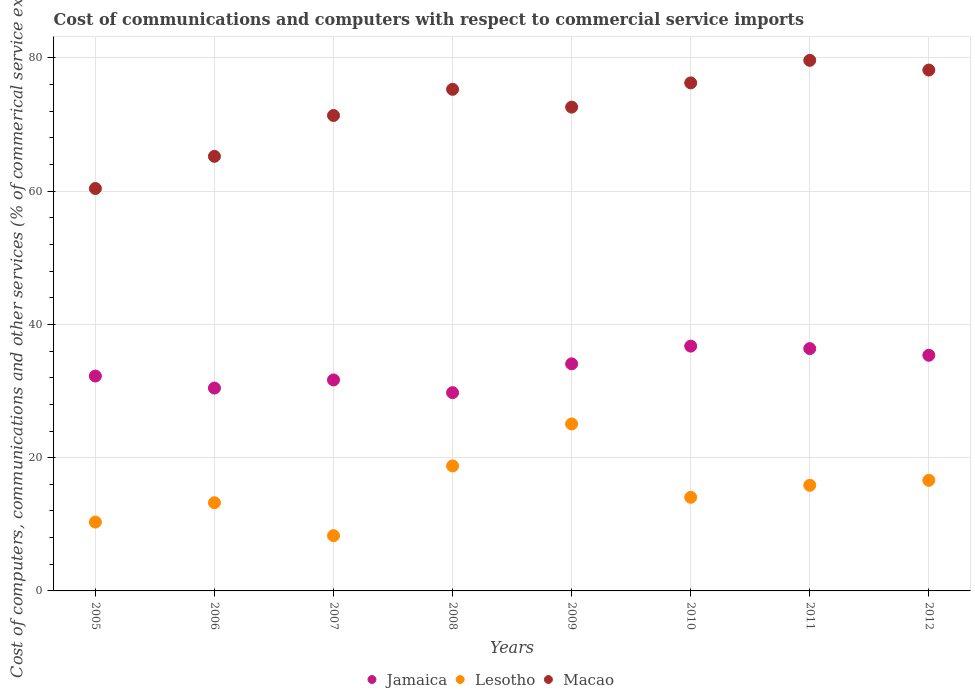Is the number of dotlines equal to the number of legend labels?
Your answer should be very brief. Yes. What is the cost of communications and computers in Lesotho in 2009?
Give a very brief answer. 25.06. Across all years, what is the maximum cost of communications and computers in Jamaica?
Offer a terse response. 36.75. Across all years, what is the minimum cost of communications and computers in Lesotho?
Give a very brief answer. 8.29. In which year was the cost of communications and computers in Macao minimum?
Offer a very short reply. 2005. What is the total cost of communications and computers in Lesotho in the graph?
Make the answer very short. 122.21. What is the difference between the cost of communications and computers in Jamaica in 2006 and that in 2012?
Offer a very short reply. -4.92. What is the difference between the cost of communications and computers in Jamaica in 2005 and the cost of communications and computers in Macao in 2007?
Your response must be concise. -39.11. What is the average cost of communications and computers in Macao per year?
Provide a succinct answer. 72.38. In the year 2007, what is the difference between the cost of communications and computers in Macao and cost of communications and computers in Jamaica?
Make the answer very short. 39.7. What is the ratio of the cost of communications and computers in Macao in 2006 to that in 2008?
Offer a very short reply. 0.87. Is the cost of communications and computers in Lesotho in 2006 less than that in 2010?
Offer a terse response. Yes. What is the difference between the highest and the second highest cost of communications and computers in Macao?
Your answer should be very brief. 1.46. What is the difference between the highest and the lowest cost of communications and computers in Jamaica?
Your response must be concise. 6.99. In how many years, is the cost of communications and computers in Macao greater than the average cost of communications and computers in Macao taken over all years?
Make the answer very short. 5. Is the sum of the cost of communications and computers in Jamaica in 2009 and 2012 greater than the maximum cost of communications and computers in Lesotho across all years?
Your response must be concise. Yes. Does the cost of communications and computers in Jamaica monotonically increase over the years?
Keep it short and to the point. No. Is the cost of communications and computers in Jamaica strictly less than the cost of communications and computers in Lesotho over the years?
Keep it short and to the point. No. How many years are there in the graph?
Keep it short and to the point. 8. What is the difference between two consecutive major ticks on the Y-axis?
Provide a succinct answer. 20. Does the graph contain grids?
Your answer should be very brief. Yes. How are the legend labels stacked?
Your response must be concise. Horizontal. What is the title of the graph?
Make the answer very short. Cost of communications and computers with respect to commercial service imports. Does "Tanzania" appear as one of the legend labels in the graph?
Provide a succinct answer. No. What is the label or title of the Y-axis?
Make the answer very short. Cost of computers, communications and other services (% of commerical service exports). What is the Cost of computers, communications and other services (% of commerical service exports) in Jamaica in 2005?
Keep it short and to the point. 32.25. What is the Cost of computers, communications and other services (% of commerical service exports) of Lesotho in 2005?
Give a very brief answer. 10.33. What is the Cost of computers, communications and other services (% of commerical service exports) of Macao in 2005?
Provide a short and direct response. 60.41. What is the Cost of computers, communications and other services (% of commerical service exports) of Jamaica in 2006?
Keep it short and to the point. 30.45. What is the Cost of computers, communications and other services (% of commerical service exports) of Lesotho in 2006?
Provide a succinct answer. 13.24. What is the Cost of computers, communications and other services (% of commerical service exports) in Macao in 2006?
Your response must be concise. 65.24. What is the Cost of computers, communications and other services (% of commerical service exports) of Jamaica in 2007?
Make the answer very short. 31.67. What is the Cost of computers, communications and other services (% of commerical service exports) in Lesotho in 2007?
Your answer should be compact. 8.29. What is the Cost of computers, communications and other services (% of commerical service exports) of Macao in 2007?
Your answer should be compact. 71.37. What is the Cost of computers, communications and other services (% of commerical service exports) in Jamaica in 2008?
Your answer should be very brief. 29.76. What is the Cost of computers, communications and other services (% of commerical service exports) in Lesotho in 2008?
Provide a short and direct response. 18.77. What is the Cost of computers, communications and other services (% of commerical service exports) in Macao in 2008?
Make the answer very short. 75.3. What is the Cost of computers, communications and other services (% of commerical service exports) of Jamaica in 2009?
Ensure brevity in your answer.  34.09. What is the Cost of computers, communications and other services (% of commerical service exports) in Lesotho in 2009?
Your answer should be very brief. 25.06. What is the Cost of computers, communications and other services (% of commerical service exports) in Macao in 2009?
Your response must be concise. 72.62. What is the Cost of computers, communications and other services (% of commerical service exports) in Jamaica in 2010?
Your response must be concise. 36.75. What is the Cost of computers, communications and other services (% of commerical service exports) in Lesotho in 2010?
Provide a short and direct response. 14.05. What is the Cost of computers, communications and other services (% of commerical service exports) in Macao in 2010?
Keep it short and to the point. 76.26. What is the Cost of computers, communications and other services (% of commerical service exports) in Jamaica in 2011?
Give a very brief answer. 36.37. What is the Cost of computers, communications and other services (% of commerical service exports) in Lesotho in 2011?
Your response must be concise. 15.86. What is the Cost of computers, communications and other services (% of commerical service exports) in Macao in 2011?
Offer a very short reply. 79.65. What is the Cost of computers, communications and other services (% of commerical service exports) in Jamaica in 2012?
Make the answer very short. 35.37. What is the Cost of computers, communications and other services (% of commerical service exports) of Lesotho in 2012?
Make the answer very short. 16.6. What is the Cost of computers, communications and other services (% of commerical service exports) of Macao in 2012?
Your response must be concise. 78.19. Across all years, what is the maximum Cost of computers, communications and other services (% of commerical service exports) in Jamaica?
Offer a very short reply. 36.75. Across all years, what is the maximum Cost of computers, communications and other services (% of commerical service exports) in Lesotho?
Offer a very short reply. 25.06. Across all years, what is the maximum Cost of computers, communications and other services (% of commerical service exports) of Macao?
Your answer should be very brief. 79.65. Across all years, what is the minimum Cost of computers, communications and other services (% of commerical service exports) in Jamaica?
Offer a very short reply. 29.76. Across all years, what is the minimum Cost of computers, communications and other services (% of commerical service exports) of Lesotho?
Your response must be concise. 8.29. Across all years, what is the minimum Cost of computers, communications and other services (% of commerical service exports) of Macao?
Give a very brief answer. 60.41. What is the total Cost of computers, communications and other services (% of commerical service exports) in Jamaica in the graph?
Keep it short and to the point. 266.71. What is the total Cost of computers, communications and other services (% of commerical service exports) in Lesotho in the graph?
Offer a terse response. 122.21. What is the total Cost of computers, communications and other services (% of commerical service exports) of Macao in the graph?
Give a very brief answer. 579.03. What is the difference between the Cost of computers, communications and other services (% of commerical service exports) of Jamaica in 2005 and that in 2006?
Offer a terse response. 1.8. What is the difference between the Cost of computers, communications and other services (% of commerical service exports) of Lesotho in 2005 and that in 2006?
Make the answer very short. -2.9. What is the difference between the Cost of computers, communications and other services (% of commerical service exports) of Macao in 2005 and that in 2006?
Your answer should be compact. -4.83. What is the difference between the Cost of computers, communications and other services (% of commerical service exports) in Jamaica in 2005 and that in 2007?
Keep it short and to the point. 0.58. What is the difference between the Cost of computers, communications and other services (% of commerical service exports) of Lesotho in 2005 and that in 2007?
Provide a succinct answer. 2.04. What is the difference between the Cost of computers, communications and other services (% of commerical service exports) of Macao in 2005 and that in 2007?
Offer a terse response. -10.96. What is the difference between the Cost of computers, communications and other services (% of commerical service exports) of Jamaica in 2005 and that in 2008?
Your response must be concise. 2.49. What is the difference between the Cost of computers, communications and other services (% of commerical service exports) of Lesotho in 2005 and that in 2008?
Offer a very short reply. -8.43. What is the difference between the Cost of computers, communications and other services (% of commerical service exports) of Macao in 2005 and that in 2008?
Keep it short and to the point. -14.89. What is the difference between the Cost of computers, communications and other services (% of commerical service exports) in Jamaica in 2005 and that in 2009?
Offer a very short reply. -1.83. What is the difference between the Cost of computers, communications and other services (% of commerical service exports) in Lesotho in 2005 and that in 2009?
Provide a short and direct response. -14.73. What is the difference between the Cost of computers, communications and other services (% of commerical service exports) of Macao in 2005 and that in 2009?
Give a very brief answer. -12.22. What is the difference between the Cost of computers, communications and other services (% of commerical service exports) of Jamaica in 2005 and that in 2010?
Make the answer very short. -4.49. What is the difference between the Cost of computers, communications and other services (% of commerical service exports) of Lesotho in 2005 and that in 2010?
Keep it short and to the point. -3.72. What is the difference between the Cost of computers, communications and other services (% of commerical service exports) of Macao in 2005 and that in 2010?
Make the answer very short. -15.85. What is the difference between the Cost of computers, communications and other services (% of commerical service exports) of Jamaica in 2005 and that in 2011?
Your answer should be very brief. -4.12. What is the difference between the Cost of computers, communications and other services (% of commerical service exports) of Lesotho in 2005 and that in 2011?
Your answer should be very brief. -5.52. What is the difference between the Cost of computers, communications and other services (% of commerical service exports) in Macao in 2005 and that in 2011?
Make the answer very short. -19.24. What is the difference between the Cost of computers, communications and other services (% of commerical service exports) of Jamaica in 2005 and that in 2012?
Provide a short and direct response. -3.12. What is the difference between the Cost of computers, communications and other services (% of commerical service exports) of Lesotho in 2005 and that in 2012?
Make the answer very short. -6.27. What is the difference between the Cost of computers, communications and other services (% of commerical service exports) of Macao in 2005 and that in 2012?
Provide a short and direct response. -17.78. What is the difference between the Cost of computers, communications and other services (% of commerical service exports) of Jamaica in 2006 and that in 2007?
Give a very brief answer. -1.22. What is the difference between the Cost of computers, communications and other services (% of commerical service exports) in Lesotho in 2006 and that in 2007?
Your answer should be compact. 4.95. What is the difference between the Cost of computers, communications and other services (% of commerical service exports) in Macao in 2006 and that in 2007?
Give a very brief answer. -6.13. What is the difference between the Cost of computers, communications and other services (% of commerical service exports) in Jamaica in 2006 and that in 2008?
Offer a very short reply. 0.69. What is the difference between the Cost of computers, communications and other services (% of commerical service exports) of Lesotho in 2006 and that in 2008?
Your response must be concise. -5.53. What is the difference between the Cost of computers, communications and other services (% of commerical service exports) in Macao in 2006 and that in 2008?
Provide a short and direct response. -10.06. What is the difference between the Cost of computers, communications and other services (% of commerical service exports) in Jamaica in 2006 and that in 2009?
Your response must be concise. -3.64. What is the difference between the Cost of computers, communications and other services (% of commerical service exports) in Lesotho in 2006 and that in 2009?
Offer a very short reply. -11.82. What is the difference between the Cost of computers, communications and other services (% of commerical service exports) in Macao in 2006 and that in 2009?
Your answer should be compact. -7.39. What is the difference between the Cost of computers, communications and other services (% of commerical service exports) of Jamaica in 2006 and that in 2010?
Provide a short and direct response. -6.3. What is the difference between the Cost of computers, communications and other services (% of commerical service exports) of Lesotho in 2006 and that in 2010?
Your answer should be compact. -0.82. What is the difference between the Cost of computers, communications and other services (% of commerical service exports) in Macao in 2006 and that in 2010?
Provide a short and direct response. -11.02. What is the difference between the Cost of computers, communications and other services (% of commerical service exports) in Jamaica in 2006 and that in 2011?
Give a very brief answer. -5.92. What is the difference between the Cost of computers, communications and other services (% of commerical service exports) of Lesotho in 2006 and that in 2011?
Ensure brevity in your answer.  -2.62. What is the difference between the Cost of computers, communications and other services (% of commerical service exports) of Macao in 2006 and that in 2011?
Offer a terse response. -14.41. What is the difference between the Cost of computers, communications and other services (% of commerical service exports) of Jamaica in 2006 and that in 2012?
Offer a very short reply. -4.92. What is the difference between the Cost of computers, communications and other services (% of commerical service exports) in Lesotho in 2006 and that in 2012?
Give a very brief answer. -3.37. What is the difference between the Cost of computers, communications and other services (% of commerical service exports) in Macao in 2006 and that in 2012?
Offer a very short reply. -12.95. What is the difference between the Cost of computers, communications and other services (% of commerical service exports) of Jamaica in 2007 and that in 2008?
Your response must be concise. 1.91. What is the difference between the Cost of computers, communications and other services (% of commerical service exports) of Lesotho in 2007 and that in 2008?
Keep it short and to the point. -10.47. What is the difference between the Cost of computers, communications and other services (% of commerical service exports) of Macao in 2007 and that in 2008?
Your answer should be compact. -3.93. What is the difference between the Cost of computers, communications and other services (% of commerical service exports) in Jamaica in 2007 and that in 2009?
Keep it short and to the point. -2.42. What is the difference between the Cost of computers, communications and other services (% of commerical service exports) of Lesotho in 2007 and that in 2009?
Offer a terse response. -16.77. What is the difference between the Cost of computers, communications and other services (% of commerical service exports) of Macao in 2007 and that in 2009?
Your answer should be very brief. -1.26. What is the difference between the Cost of computers, communications and other services (% of commerical service exports) in Jamaica in 2007 and that in 2010?
Keep it short and to the point. -5.08. What is the difference between the Cost of computers, communications and other services (% of commerical service exports) of Lesotho in 2007 and that in 2010?
Your response must be concise. -5.76. What is the difference between the Cost of computers, communications and other services (% of commerical service exports) in Macao in 2007 and that in 2010?
Keep it short and to the point. -4.89. What is the difference between the Cost of computers, communications and other services (% of commerical service exports) of Jamaica in 2007 and that in 2011?
Make the answer very short. -4.7. What is the difference between the Cost of computers, communications and other services (% of commerical service exports) in Lesotho in 2007 and that in 2011?
Offer a very short reply. -7.56. What is the difference between the Cost of computers, communications and other services (% of commerical service exports) of Macao in 2007 and that in 2011?
Your answer should be compact. -8.28. What is the difference between the Cost of computers, communications and other services (% of commerical service exports) in Jamaica in 2007 and that in 2012?
Ensure brevity in your answer.  -3.7. What is the difference between the Cost of computers, communications and other services (% of commerical service exports) of Lesotho in 2007 and that in 2012?
Provide a short and direct response. -8.31. What is the difference between the Cost of computers, communications and other services (% of commerical service exports) in Macao in 2007 and that in 2012?
Your answer should be very brief. -6.82. What is the difference between the Cost of computers, communications and other services (% of commerical service exports) of Jamaica in 2008 and that in 2009?
Your answer should be compact. -4.33. What is the difference between the Cost of computers, communications and other services (% of commerical service exports) of Lesotho in 2008 and that in 2009?
Make the answer very short. -6.3. What is the difference between the Cost of computers, communications and other services (% of commerical service exports) of Macao in 2008 and that in 2009?
Offer a terse response. 2.67. What is the difference between the Cost of computers, communications and other services (% of commerical service exports) in Jamaica in 2008 and that in 2010?
Keep it short and to the point. -6.99. What is the difference between the Cost of computers, communications and other services (% of commerical service exports) of Lesotho in 2008 and that in 2010?
Provide a succinct answer. 4.71. What is the difference between the Cost of computers, communications and other services (% of commerical service exports) of Macao in 2008 and that in 2010?
Your answer should be compact. -0.96. What is the difference between the Cost of computers, communications and other services (% of commerical service exports) of Jamaica in 2008 and that in 2011?
Offer a terse response. -6.61. What is the difference between the Cost of computers, communications and other services (% of commerical service exports) in Lesotho in 2008 and that in 2011?
Provide a short and direct response. 2.91. What is the difference between the Cost of computers, communications and other services (% of commerical service exports) of Macao in 2008 and that in 2011?
Offer a very short reply. -4.35. What is the difference between the Cost of computers, communications and other services (% of commerical service exports) in Jamaica in 2008 and that in 2012?
Keep it short and to the point. -5.61. What is the difference between the Cost of computers, communications and other services (% of commerical service exports) in Lesotho in 2008 and that in 2012?
Give a very brief answer. 2.16. What is the difference between the Cost of computers, communications and other services (% of commerical service exports) in Macao in 2008 and that in 2012?
Make the answer very short. -2.89. What is the difference between the Cost of computers, communications and other services (% of commerical service exports) in Jamaica in 2009 and that in 2010?
Provide a succinct answer. -2.66. What is the difference between the Cost of computers, communications and other services (% of commerical service exports) in Lesotho in 2009 and that in 2010?
Offer a very short reply. 11.01. What is the difference between the Cost of computers, communications and other services (% of commerical service exports) of Macao in 2009 and that in 2010?
Keep it short and to the point. -3.64. What is the difference between the Cost of computers, communications and other services (% of commerical service exports) in Jamaica in 2009 and that in 2011?
Your answer should be compact. -2.29. What is the difference between the Cost of computers, communications and other services (% of commerical service exports) of Lesotho in 2009 and that in 2011?
Offer a terse response. 9.21. What is the difference between the Cost of computers, communications and other services (% of commerical service exports) of Macao in 2009 and that in 2011?
Your response must be concise. -7.02. What is the difference between the Cost of computers, communications and other services (% of commerical service exports) of Jamaica in 2009 and that in 2012?
Your response must be concise. -1.29. What is the difference between the Cost of computers, communications and other services (% of commerical service exports) in Lesotho in 2009 and that in 2012?
Make the answer very short. 8.46. What is the difference between the Cost of computers, communications and other services (% of commerical service exports) of Macao in 2009 and that in 2012?
Provide a short and direct response. -5.56. What is the difference between the Cost of computers, communications and other services (% of commerical service exports) of Jamaica in 2010 and that in 2011?
Your response must be concise. 0.37. What is the difference between the Cost of computers, communications and other services (% of commerical service exports) in Lesotho in 2010 and that in 2011?
Provide a succinct answer. -1.8. What is the difference between the Cost of computers, communications and other services (% of commerical service exports) in Macao in 2010 and that in 2011?
Make the answer very short. -3.39. What is the difference between the Cost of computers, communications and other services (% of commerical service exports) in Jamaica in 2010 and that in 2012?
Provide a succinct answer. 1.37. What is the difference between the Cost of computers, communications and other services (% of commerical service exports) in Lesotho in 2010 and that in 2012?
Your answer should be compact. -2.55. What is the difference between the Cost of computers, communications and other services (% of commerical service exports) in Macao in 2010 and that in 2012?
Ensure brevity in your answer.  -1.93. What is the difference between the Cost of computers, communications and other services (% of commerical service exports) of Lesotho in 2011 and that in 2012?
Offer a terse response. -0.75. What is the difference between the Cost of computers, communications and other services (% of commerical service exports) of Macao in 2011 and that in 2012?
Keep it short and to the point. 1.46. What is the difference between the Cost of computers, communications and other services (% of commerical service exports) of Jamaica in 2005 and the Cost of computers, communications and other services (% of commerical service exports) of Lesotho in 2006?
Make the answer very short. 19.01. What is the difference between the Cost of computers, communications and other services (% of commerical service exports) of Jamaica in 2005 and the Cost of computers, communications and other services (% of commerical service exports) of Macao in 2006?
Offer a terse response. -32.98. What is the difference between the Cost of computers, communications and other services (% of commerical service exports) of Lesotho in 2005 and the Cost of computers, communications and other services (% of commerical service exports) of Macao in 2006?
Your answer should be very brief. -54.9. What is the difference between the Cost of computers, communications and other services (% of commerical service exports) in Jamaica in 2005 and the Cost of computers, communications and other services (% of commerical service exports) in Lesotho in 2007?
Keep it short and to the point. 23.96. What is the difference between the Cost of computers, communications and other services (% of commerical service exports) of Jamaica in 2005 and the Cost of computers, communications and other services (% of commerical service exports) of Macao in 2007?
Your answer should be very brief. -39.11. What is the difference between the Cost of computers, communications and other services (% of commerical service exports) in Lesotho in 2005 and the Cost of computers, communications and other services (% of commerical service exports) in Macao in 2007?
Your response must be concise. -61.03. What is the difference between the Cost of computers, communications and other services (% of commerical service exports) in Jamaica in 2005 and the Cost of computers, communications and other services (% of commerical service exports) in Lesotho in 2008?
Provide a succinct answer. 13.49. What is the difference between the Cost of computers, communications and other services (% of commerical service exports) in Jamaica in 2005 and the Cost of computers, communications and other services (% of commerical service exports) in Macao in 2008?
Provide a succinct answer. -43.04. What is the difference between the Cost of computers, communications and other services (% of commerical service exports) in Lesotho in 2005 and the Cost of computers, communications and other services (% of commerical service exports) in Macao in 2008?
Your response must be concise. -64.96. What is the difference between the Cost of computers, communications and other services (% of commerical service exports) of Jamaica in 2005 and the Cost of computers, communications and other services (% of commerical service exports) of Lesotho in 2009?
Offer a terse response. 7.19. What is the difference between the Cost of computers, communications and other services (% of commerical service exports) of Jamaica in 2005 and the Cost of computers, communications and other services (% of commerical service exports) of Macao in 2009?
Offer a very short reply. -40.37. What is the difference between the Cost of computers, communications and other services (% of commerical service exports) of Lesotho in 2005 and the Cost of computers, communications and other services (% of commerical service exports) of Macao in 2009?
Give a very brief answer. -62.29. What is the difference between the Cost of computers, communications and other services (% of commerical service exports) in Jamaica in 2005 and the Cost of computers, communications and other services (% of commerical service exports) in Lesotho in 2010?
Provide a succinct answer. 18.2. What is the difference between the Cost of computers, communications and other services (% of commerical service exports) in Jamaica in 2005 and the Cost of computers, communications and other services (% of commerical service exports) in Macao in 2010?
Provide a succinct answer. -44.01. What is the difference between the Cost of computers, communications and other services (% of commerical service exports) of Lesotho in 2005 and the Cost of computers, communications and other services (% of commerical service exports) of Macao in 2010?
Offer a terse response. -65.93. What is the difference between the Cost of computers, communications and other services (% of commerical service exports) in Jamaica in 2005 and the Cost of computers, communications and other services (% of commerical service exports) in Lesotho in 2011?
Your response must be concise. 16.4. What is the difference between the Cost of computers, communications and other services (% of commerical service exports) of Jamaica in 2005 and the Cost of computers, communications and other services (% of commerical service exports) of Macao in 2011?
Provide a short and direct response. -47.39. What is the difference between the Cost of computers, communications and other services (% of commerical service exports) in Lesotho in 2005 and the Cost of computers, communications and other services (% of commerical service exports) in Macao in 2011?
Ensure brevity in your answer.  -69.31. What is the difference between the Cost of computers, communications and other services (% of commerical service exports) in Jamaica in 2005 and the Cost of computers, communications and other services (% of commerical service exports) in Lesotho in 2012?
Provide a short and direct response. 15.65. What is the difference between the Cost of computers, communications and other services (% of commerical service exports) of Jamaica in 2005 and the Cost of computers, communications and other services (% of commerical service exports) of Macao in 2012?
Provide a succinct answer. -45.94. What is the difference between the Cost of computers, communications and other services (% of commerical service exports) of Lesotho in 2005 and the Cost of computers, communications and other services (% of commerical service exports) of Macao in 2012?
Keep it short and to the point. -67.85. What is the difference between the Cost of computers, communications and other services (% of commerical service exports) of Jamaica in 2006 and the Cost of computers, communications and other services (% of commerical service exports) of Lesotho in 2007?
Give a very brief answer. 22.16. What is the difference between the Cost of computers, communications and other services (% of commerical service exports) of Jamaica in 2006 and the Cost of computers, communications and other services (% of commerical service exports) of Macao in 2007?
Your answer should be very brief. -40.92. What is the difference between the Cost of computers, communications and other services (% of commerical service exports) of Lesotho in 2006 and the Cost of computers, communications and other services (% of commerical service exports) of Macao in 2007?
Your answer should be compact. -58.13. What is the difference between the Cost of computers, communications and other services (% of commerical service exports) in Jamaica in 2006 and the Cost of computers, communications and other services (% of commerical service exports) in Lesotho in 2008?
Keep it short and to the point. 11.68. What is the difference between the Cost of computers, communications and other services (% of commerical service exports) of Jamaica in 2006 and the Cost of computers, communications and other services (% of commerical service exports) of Macao in 2008?
Offer a terse response. -44.85. What is the difference between the Cost of computers, communications and other services (% of commerical service exports) in Lesotho in 2006 and the Cost of computers, communications and other services (% of commerical service exports) in Macao in 2008?
Offer a very short reply. -62.06. What is the difference between the Cost of computers, communications and other services (% of commerical service exports) in Jamaica in 2006 and the Cost of computers, communications and other services (% of commerical service exports) in Lesotho in 2009?
Your response must be concise. 5.39. What is the difference between the Cost of computers, communications and other services (% of commerical service exports) of Jamaica in 2006 and the Cost of computers, communications and other services (% of commerical service exports) of Macao in 2009?
Your answer should be compact. -42.17. What is the difference between the Cost of computers, communications and other services (% of commerical service exports) of Lesotho in 2006 and the Cost of computers, communications and other services (% of commerical service exports) of Macao in 2009?
Make the answer very short. -59.39. What is the difference between the Cost of computers, communications and other services (% of commerical service exports) in Jamaica in 2006 and the Cost of computers, communications and other services (% of commerical service exports) in Lesotho in 2010?
Give a very brief answer. 16.4. What is the difference between the Cost of computers, communications and other services (% of commerical service exports) of Jamaica in 2006 and the Cost of computers, communications and other services (% of commerical service exports) of Macao in 2010?
Offer a terse response. -45.81. What is the difference between the Cost of computers, communications and other services (% of commerical service exports) in Lesotho in 2006 and the Cost of computers, communications and other services (% of commerical service exports) in Macao in 2010?
Keep it short and to the point. -63.02. What is the difference between the Cost of computers, communications and other services (% of commerical service exports) of Jamaica in 2006 and the Cost of computers, communications and other services (% of commerical service exports) of Lesotho in 2011?
Provide a short and direct response. 14.59. What is the difference between the Cost of computers, communications and other services (% of commerical service exports) of Jamaica in 2006 and the Cost of computers, communications and other services (% of commerical service exports) of Macao in 2011?
Make the answer very short. -49.2. What is the difference between the Cost of computers, communications and other services (% of commerical service exports) of Lesotho in 2006 and the Cost of computers, communications and other services (% of commerical service exports) of Macao in 2011?
Provide a short and direct response. -66.41. What is the difference between the Cost of computers, communications and other services (% of commerical service exports) in Jamaica in 2006 and the Cost of computers, communications and other services (% of commerical service exports) in Lesotho in 2012?
Provide a short and direct response. 13.85. What is the difference between the Cost of computers, communications and other services (% of commerical service exports) in Jamaica in 2006 and the Cost of computers, communications and other services (% of commerical service exports) in Macao in 2012?
Keep it short and to the point. -47.74. What is the difference between the Cost of computers, communications and other services (% of commerical service exports) of Lesotho in 2006 and the Cost of computers, communications and other services (% of commerical service exports) of Macao in 2012?
Ensure brevity in your answer.  -64.95. What is the difference between the Cost of computers, communications and other services (% of commerical service exports) in Jamaica in 2007 and the Cost of computers, communications and other services (% of commerical service exports) in Lesotho in 2008?
Make the answer very short. 12.9. What is the difference between the Cost of computers, communications and other services (% of commerical service exports) in Jamaica in 2007 and the Cost of computers, communications and other services (% of commerical service exports) in Macao in 2008?
Your response must be concise. -43.63. What is the difference between the Cost of computers, communications and other services (% of commerical service exports) in Lesotho in 2007 and the Cost of computers, communications and other services (% of commerical service exports) in Macao in 2008?
Give a very brief answer. -67. What is the difference between the Cost of computers, communications and other services (% of commerical service exports) of Jamaica in 2007 and the Cost of computers, communications and other services (% of commerical service exports) of Lesotho in 2009?
Your answer should be very brief. 6.61. What is the difference between the Cost of computers, communications and other services (% of commerical service exports) of Jamaica in 2007 and the Cost of computers, communications and other services (% of commerical service exports) of Macao in 2009?
Give a very brief answer. -40.95. What is the difference between the Cost of computers, communications and other services (% of commerical service exports) in Lesotho in 2007 and the Cost of computers, communications and other services (% of commerical service exports) in Macao in 2009?
Provide a short and direct response. -64.33. What is the difference between the Cost of computers, communications and other services (% of commerical service exports) in Jamaica in 2007 and the Cost of computers, communications and other services (% of commerical service exports) in Lesotho in 2010?
Your answer should be compact. 17.62. What is the difference between the Cost of computers, communications and other services (% of commerical service exports) in Jamaica in 2007 and the Cost of computers, communications and other services (% of commerical service exports) in Macao in 2010?
Provide a succinct answer. -44.59. What is the difference between the Cost of computers, communications and other services (% of commerical service exports) of Lesotho in 2007 and the Cost of computers, communications and other services (% of commerical service exports) of Macao in 2010?
Your answer should be very brief. -67.97. What is the difference between the Cost of computers, communications and other services (% of commerical service exports) of Jamaica in 2007 and the Cost of computers, communications and other services (% of commerical service exports) of Lesotho in 2011?
Provide a succinct answer. 15.81. What is the difference between the Cost of computers, communications and other services (% of commerical service exports) in Jamaica in 2007 and the Cost of computers, communications and other services (% of commerical service exports) in Macao in 2011?
Ensure brevity in your answer.  -47.98. What is the difference between the Cost of computers, communications and other services (% of commerical service exports) in Lesotho in 2007 and the Cost of computers, communications and other services (% of commerical service exports) in Macao in 2011?
Provide a succinct answer. -71.35. What is the difference between the Cost of computers, communications and other services (% of commerical service exports) of Jamaica in 2007 and the Cost of computers, communications and other services (% of commerical service exports) of Lesotho in 2012?
Provide a short and direct response. 15.07. What is the difference between the Cost of computers, communications and other services (% of commerical service exports) in Jamaica in 2007 and the Cost of computers, communications and other services (% of commerical service exports) in Macao in 2012?
Keep it short and to the point. -46.52. What is the difference between the Cost of computers, communications and other services (% of commerical service exports) of Lesotho in 2007 and the Cost of computers, communications and other services (% of commerical service exports) of Macao in 2012?
Keep it short and to the point. -69.89. What is the difference between the Cost of computers, communications and other services (% of commerical service exports) in Jamaica in 2008 and the Cost of computers, communications and other services (% of commerical service exports) in Lesotho in 2009?
Offer a very short reply. 4.7. What is the difference between the Cost of computers, communications and other services (% of commerical service exports) of Jamaica in 2008 and the Cost of computers, communications and other services (% of commerical service exports) of Macao in 2009?
Ensure brevity in your answer.  -42.86. What is the difference between the Cost of computers, communications and other services (% of commerical service exports) of Lesotho in 2008 and the Cost of computers, communications and other services (% of commerical service exports) of Macao in 2009?
Ensure brevity in your answer.  -53.86. What is the difference between the Cost of computers, communications and other services (% of commerical service exports) of Jamaica in 2008 and the Cost of computers, communications and other services (% of commerical service exports) of Lesotho in 2010?
Your answer should be very brief. 15.71. What is the difference between the Cost of computers, communications and other services (% of commerical service exports) of Jamaica in 2008 and the Cost of computers, communications and other services (% of commerical service exports) of Macao in 2010?
Ensure brevity in your answer.  -46.5. What is the difference between the Cost of computers, communications and other services (% of commerical service exports) of Lesotho in 2008 and the Cost of computers, communications and other services (% of commerical service exports) of Macao in 2010?
Provide a succinct answer. -57.49. What is the difference between the Cost of computers, communications and other services (% of commerical service exports) of Jamaica in 2008 and the Cost of computers, communications and other services (% of commerical service exports) of Lesotho in 2011?
Make the answer very short. 13.9. What is the difference between the Cost of computers, communications and other services (% of commerical service exports) of Jamaica in 2008 and the Cost of computers, communications and other services (% of commerical service exports) of Macao in 2011?
Offer a very short reply. -49.89. What is the difference between the Cost of computers, communications and other services (% of commerical service exports) in Lesotho in 2008 and the Cost of computers, communications and other services (% of commerical service exports) in Macao in 2011?
Provide a succinct answer. -60.88. What is the difference between the Cost of computers, communications and other services (% of commerical service exports) of Jamaica in 2008 and the Cost of computers, communications and other services (% of commerical service exports) of Lesotho in 2012?
Your answer should be very brief. 13.16. What is the difference between the Cost of computers, communications and other services (% of commerical service exports) of Jamaica in 2008 and the Cost of computers, communications and other services (% of commerical service exports) of Macao in 2012?
Keep it short and to the point. -48.43. What is the difference between the Cost of computers, communications and other services (% of commerical service exports) in Lesotho in 2008 and the Cost of computers, communications and other services (% of commerical service exports) in Macao in 2012?
Provide a short and direct response. -59.42. What is the difference between the Cost of computers, communications and other services (% of commerical service exports) in Jamaica in 2009 and the Cost of computers, communications and other services (% of commerical service exports) in Lesotho in 2010?
Provide a succinct answer. 20.03. What is the difference between the Cost of computers, communications and other services (% of commerical service exports) of Jamaica in 2009 and the Cost of computers, communications and other services (% of commerical service exports) of Macao in 2010?
Provide a short and direct response. -42.17. What is the difference between the Cost of computers, communications and other services (% of commerical service exports) in Lesotho in 2009 and the Cost of computers, communications and other services (% of commerical service exports) in Macao in 2010?
Provide a short and direct response. -51.2. What is the difference between the Cost of computers, communications and other services (% of commerical service exports) of Jamaica in 2009 and the Cost of computers, communications and other services (% of commerical service exports) of Lesotho in 2011?
Ensure brevity in your answer.  18.23. What is the difference between the Cost of computers, communications and other services (% of commerical service exports) of Jamaica in 2009 and the Cost of computers, communications and other services (% of commerical service exports) of Macao in 2011?
Offer a very short reply. -45.56. What is the difference between the Cost of computers, communications and other services (% of commerical service exports) of Lesotho in 2009 and the Cost of computers, communications and other services (% of commerical service exports) of Macao in 2011?
Your answer should be compact. -54.58. What is the difference between the Cost of computers, communications and other services (% of commerical service exports) of Jamaica in 2009 and the Cost of computers, communications and other services (% of commerical service exports) of Lesotho in 2012?
Offer a terse response. 17.48. What is the difference between the Cost of computers, communications and other services (% of commerical service exports) in Jamaica in 2009 and the Cost of computers, communications and other services (% of commerical service exports) in Macao in 2012?
Ensure brevity in your answer.  -44.1. What is the difference between the Cost of computers, communications and other services (% of commerical service exports) of Lesotho in 2009 and the Cost of computers, communications and other services (% of commerical service exports) of Macao in 2012?
Make the answer very short. -53.13. What is the difference between the Cost of computers, communications and other services (% of commerical service exports) in Jamaica in 2010 and the Cost of computers, communications and other services (% of commerical service exports) in Lesotho in 2011?
Provide a succinct answer. 20.89. What is the difference between the Cost of computers, communications and other services (% of commerical service exports) of Jamaica in 2010 and the Cost of computers, communications and other services (% of commerical service exports) of Macao in 2011?
Ensure brevity in your answer.  -42.9. What is the difference between the Cost of computers, communications and other services (% of commerical service exports) of Lesotho in 2010 and the Cost of computers, communications and other services (% of commerical service exports) of Macao in 2011?
Offer a very short reply. -65.59. What is the difference between the Cost of computers, communications and other services (% of commerical service exports) in Jamaica in 2010 and the Cost of computers, communications and other services (% of commerical service exports) in Lesotho in 2012?
Give a very brief answer. 20.14. What is the difference between the Cost of computers, communications and other services (% of commerical service exports) of Jamaica in 2010 and the Cost of computers, communications and other services (% of commerical service exports) of Macao in 2012?
Provide a succinct answer. -41.44. What is the difference between the Cost of computers, communications and other services (% of commerical service exports) in Lesotho in 2010 and the Cost of computers, communications and other services (% of commerical service exports) in Macao in 2012?
Provide a succinct answer. -64.13. What is the difference between the Cost of computers, communications and other services (% of commerical service exports) of Jamaica in 2011 and the Cost of computers, communications and other services (% of commerical service exports) of Lesotho in 2012?
Your answer should be very brief. 19.77. What is the difference between the Cost of computers, communications and other services (% of commerical service exports) in Jamaica in 2011 and the Cost of computers, communications and other services (% of commerical service exports) in Macao in 2012?
Your response must be concise. -41.82. What is the difference between the Cost of computers, communications and other services (% of commerical service exports) in Lesotho in 2011 and the Cost of computers, communications and other services (% of commerical service exports) in Macao in 2012?
Keep it short and to the point. -62.33. What is the average Cost of computers, communications and other services (% of commerical service exports) in Jamaica per year?
Offer a very short reply. 33.34. What is the average Cost of computers, communications and other services (% of commerical service exports) in Lesotho per year?
Your response must be concise. 15.28. What is the average Cost of computers, communications and other services (% of commerical service exports) in Macao per year?
Provide a succinct answer. 72.38. In the year 2005, what is the difference between the Cost of computers, communications and other services (% of commerical service exports) of Jamaica and Cost of computers, communications and other services (% of commerical service exports) of Lesotho?
Offer a terse response. 21.92. In the year 2005, what is the difference between the Cost of computers, communications and other services (% of commerical service exports) of Jamaica and Cost of computers, communications and other services (% of commerical service exports) of Macao?
Give a very brief answer. -28.15. In the year 2005, what is the difference between the Cost of computers, communications and other services (% of commerical service exports) of Lesotho and Cost of computers, communications and other services (% of commerical service exports) of Macao?
Ensure brevity in your answer.  -50.07. In the year 2006, what is the difference between the Cost of computers, communications and other services (% of commerical service exports) of Jamaica and Cost of computers, communications and other services (% of commerical service exports) of Lesotho?
Your response must be concise. 17.21. In the year 2006, what is the difference between the Cost of computers, communications and other services (% of commerical service exports) in Jamaica and Cost of computers, communications and other services (% of commerical service exports) in Macao?
Make the answer very short. -34.79. In the year 2006, what is the difference between the Cost of computers, communications and other services (% of commerical service exports) in Lesotho and Cost of computers, communications and other services (% of commerical service exports) in Macao?
Your answer should be very brief. -52. In the year 2007, what is the difference between the Cost of computers, communications and other services (% of commerical service exports) in Jamaica and Cost of computers, communications and other services (% of commerical service exports) in Lesotho?
Offer a terse response. 23.38. In the year 2007, what is the difference between the Cost of computers, communications and other services (% of commerical service exports) of Jamaica and Cost of computers, communications and other services (% of commerical service exports) of Macao?
Keep it short and to the point. -39.7. In the year 2007, what is the difference between the Cost of computers, communications and other services (% of commerical service exports) in Lesotho and Cost of computers, communications and other services (% of commerical service exports) in Macao?
Give a very brief answer. -63.07. In the year 2008, what is the difference between the Cost of computers, communications and other services (% of commerical service exports) of Jamaica and Cost of computers, communications and other services (% of commerical service exports) of Lesotho?
Your response must be concise. 10.99. In the year 2008, what is the difference between the Cost of computers, communications and other services (% of commerical service exports) in Jamaica and Cost of computers, communications and other services (% of commerical service exports) in Macao?
Give a very brief answer. -45.54. In the year 2008, what is the difference between the Cost of computers, communications and other services (% of commerical service exports) in Lesotho and Cost of computers, communications and other services (% of commerical service exports) in Macao?
Offer a very short reply. -56.53. In the year 2009, what is the difference between the Cost of computers, communications and other services (% of commerical service exports) of Jamaica and Cost of computers, communications and other services (% of commerical service exports) of Lesotho?
Your answer should be compact. 9.02. In the year 2009, what is the difference between the Cost of computers, communications and other services (% of commerical service exports) in Jamaica and Cost of computers, communications and other services (% of commerical service exports) in Macao?
Your response must be concise. -38.54. In the year 2009, what is the difference between the Cost of computers, communications and other services (% of commerical service exports) in Lesotho and Cost of computers, communications and other services (% of commerical service exports) in Macao?
Ensure brevity in your answer.  -47.56. In the year 2010, what is the difference between the Cost of computers, communications and other services (% of commerical service exports) in Jamaica and Cost of computers, communications and other services (% of commerical service exports) in Lesotho?
Your response must be concise. 22.69. In the year 2010, what is the difference between the Cost of computers, communications and other services (% of commerical service exports) in Jamaica and Cost of computers, communications and other services (% of commerical service exports) in Macao?
Your response must be concise. -39.51. In the year 2010, what is the difference between the Cost of computers, communications and other services (% of commerical service exports) in Lesotho and Cost of computers, communications and other services (% of commerical service exports) in Macao?
Your answer should be very brief. -62.21. In the year 2011, what is the difference between the Cost of computers, communications and other services (% of commerical service exports) of Jamaica and Cost of computers, communications and other services (% of commerical service exports) of Lesotho?
Provide a succinct answer. 20.52. In the year 2011, what is the difference between the Cost of computers, communications and other services (% of commerical service exports) of Jamaica and Cost of computers, communications and other services (% of commerical service exports) of Macao?
Your answer should be very brief. -43.27. In the year 2011, what is the difference between the Cost of computers, communications and other services (% of commerical service exports) in Lesotho and Cost of computers, communications and other services (% of commerical service exports) in Macao?
Offer a terse response. -63.79. In the year 2012, what is the difference between the Cost of computers, communications and other services (% of commerical service exports) of Jamaica and Cost of computers, communications and other services (% of commerical service exports) of Lesotho?
Ensure brevity in your answer.  18.77. In the year 2012, what is the difference between the Cost of computers, communications and other services (% of commerical service exports) of Jamaica and Cost of computers, communications and other services (% of commerical service exports) of Macao?
Ensure brevity in your answer.  -42.81. In the year 2012, what is the difference between the Cost of computers, communications and other services (% of commerical service exports) of Lesotho and Cost of computers, communications and other services (% of commerical service exports) of Macao?
Your response must be concise. -61.58. What is the ratio of the Cost of computers, communications and other services (% of commerical service exports) in Jamaica in 2005 to that in 2006?
Make the answer very short. 1.06. What is the ratio of the Cost of computers, communications and other services (% of commerical service exports) of Lesotho in 2005 to that in 2006?
Your response must be concise. 0.78. What is the ratio of the Cost of computers, communications and other services (% of commerical service exports) of Macao in 2005 to that in 2006?
Your response must be concise. 0.93. What is the ratio of the Cost of computers, communications and other services (% of commerical service exports) in Jamaica in 2005 to that in 2007?
Provide a succinct answer. 1.02. What is the ratio of the Cost of computers, communications and other services (% of commerical service exports) of Lesotho in 2005 to that in 2007?
Offer a very short reply. 1.25. What is the ratio of the Cost of computers, communications and other services (% of commerical service exports) of Macao in 2005 to that in 2007?
Your response must be concise. 0.85. What is the ratio of the Cost of computers, communications and other services (% of commerical service exports) in Jamaica in 2005 to that in 2008?
Provide a short and direct response. 1.08. What is the ratio of the Cost of computers, communications and other services (% of commerical service exports) of Lesotho in 2005 to that in 2008?
Ensure brevity in your answer.  0.55. What is the ratio of the Cost of computers, communications and other services (% of commerical service exports) in Macao in 2005 to that in 2008?
Give a very brief answer. 0.8. What is the ratio of the Cost of computers, communications and other services (% of commerical service exports) of Jamaica in 2005 to that in 2009?
Provide a succinct answer. 0.95. What is the ratio of the Cost of computers, communications and other services (% of commerical service exports) of Lesotho in 2005 to that in 2009?
Make the answer very short. 0.41. What is the ratio of the Cost of computers, communications and other services (% of commerical service exports) of Macao in 2005 to that in 2009?
Offer a very short reply. 0.83. What is the ratio of the Cost of computers, communications and other services (% of commerical service exports) in Jamaica in 2005 to that in 2010?
Make the answer very short. 0.88. What is the ratio of the Cost of computers, communications and other services (% of commerical service exports) in Lesotho in 2005 to that in 2010?
Make the answer very short. 0.74. What is the ratio of the Cost of computers, communications and other services (% of commerical service exports) in Macao in 2005 to that in 2010?
Give a very brief answer. 0.79. What is the ratio of the Cost of computers, communications and other services (% of commerical service exports) in Jamaica in 2005 to that in 2011?
Provide a succinct answer. 0.89. What is the ratio of the Cost of computers, communications and other services (% of commerical service exports) in Lesotho in 2005 to that in 2011?
Your answer should be very brief. 0.65. What is the ratio of the Cost of computers, communications and other services (% of commerical service exports) of Macao in 2005 to that in 2011?
Ensure brevity in your answer.  0.76. What is the ratio of the Cost of computers, communications and other services (% of commerical service exports) of Jamaica in 2005 to that in 2012?
Keep it short and to the point. 0.91. What is the ratio of the Cost of computers, communications and other services (% of commerical service exports) in Lesotho in 2005 to that in 2012?
Offer a terse response. 0.62. What is the ratio of the Cost of computers, communications and other services (% of commerical service exports) of Macao in 2005 to that in 2012?
Provide a succinct answer. 0.77. What is the ratio of the Cost of computers, communications and other services (% of commerical service exports) in Jamaica in 2006 to that in 2007?
Provide a succinct answer. 0.96. What is the ratio of the Cost of computers, communications and other services (% of commerical service exports) of Lesotho in 2006 to that in 2007?
Your response must be concise. 1.6. What is the ratio of the Cost of computers, communications and other services (% of commerical service exports) of Macao in 2006 to that in 2007?
Ensure brevity in your answer.  0.91. What is the ratio of the Cost of computers, communications and other services (% of commerical service exports) of Jamaica in 2006 to that in 2008?
Provide a short and direct response. 1.02. What is the ratio of the Cost of computers, communications and other services (% of commerical service exports) of Lesotho in 2006 to that in 2008?
Your response must be concise. 0.71. What is the ratio of the Cost of computers, communications and other services (% of commerical service exports) of Macao in 2006 to that in 2008?
Make the answer very short. 0.87. What is the ratio of the Cost of computers, communications and other services (% of commerical service exports) of Jamaica in 2006 to that in 2009?
Ensure brevity in your answer.  0.89. What is the ratio of the Cost of computers, communications and other services (% of commerical service exports) in Lesotho in 2006 to that in 2009?
Provide a succinct answer. 0.53. What is the ratio of the Cost of computers, communications and other services (% of commerical service exports) of Macao in 2006 to that in 2009?
Offer a terse response. 0.9. What is the ratio of the Cost of computers, communications and other services (% of commerical service exports) in Jamaica in 2006 to that in 2010?
Provide a short and direct response. 0.83. What is the ratio of the Cost of computers, communications and other services (% of commerical service exports) of Lesotho in 2006 to that in 2010?
Make the answer very short. 0.94. What is the ratio of the Cost of computers, communications and other services (% of commerical service exports) of Macao in 2006 to that in 2010?
Offer a very short reply. 0.86. What is the ratio of the Cost of computers, communications and other services (% of commerical service exports) in Jamaica in 2006 to that in 2011?
Make the answer very short. 0.84. What is the ratio of the Cost of computers, communications and other services (% of commerical service exports) of Lesotho in 2006 to that in 2011?
Provide a short and direct response. 0.83. What is the ratio of the Cost of computers, communications and other services (% of commerical service exports) of Macao in 2006 to that in 2011?
Offer a very short reply. 0.82. What is the ratio of the Cost of computers, communications and other services (% of commerical service exports) in Jamaica in 2006 to that in 2012?
Offer a very short reply. 0.86. What is the ratio of the Cost of computers, communications and other services (% of commerical service exports) in Lesotho in 2006 to that in 2012?
Provide a short and direct response. 0.8. What is the ratio of the Cost of computers, communications and other services (% of commerical service exports) in Macao in 2006 to that in 2012?
Ensure brevity in your answer.  0.83. What is the ratio of the Cost of computers, communications and other services (% of commerical service exports) in Jamaica in 2007 to that in 2008?
Your answer should be compact. 1.06. What is the ratio of the Cost of computers, communications and other services (% of commerical service exports) in Lesotho in 2007 to that in 2008?
Ensure brevity in your answer.  0.44. What is the ratio of the Cost of computers, communications and other services (% of commerical service exports) of Macao in 2007 to that in 2008?
Make the answer very short. 0.95. What is the ratio of the Cost of computers, communications and other services (% of commerical service exports) in Jamaica in 2007 to that in 2009?
Your answer should be very brief. 0.93. What is the ratio of the Cost of computers, communications and other services (% of commerical service exports) in Lesotho in 2007 to that in 2009?
Offer a very short reply. 0.33. What is the ratio of the Cost of computers, communications and other services (% of commerical service exports) of Macao in 2007 to that in 2009?
Offer a very short reply. 0.98. What is the ratio of the Cost of computers, communications and other services (% of commerical service exports) of Jamaica in 2007 to that in 2010?
Make the answer very short. 0.86. What is the ratio of the Cost of computers, communications and other services (% of commerical service exports) in Lesotho in 2007 to that in 2010?
Provide a short and direct response. 0.59. What is the ratio of the Cost of computers, communications and other services (% of commerical service exports) in Macao in 2007 to that in 2010?
Your answer should be very brief. 0.94. What is the ratio of the Cost of computers, communications and other services (% of commerical service exports) in Jamaica in 2007 to that in 2011?
Give a very brief answer. 0.87. What is the ratio of the Cost of computers, communications and other services (% of commerical service exports) of Lesotho in 2007 to that in 2011?
Ensure brevity in your answer.  0.52. What is the ratio of the Cost of computers, communications and other services (% of commerical service exports) in Macao in 2007 to that in 2011?
Ensure brevity in your answer.  0.9. What is the ratio of the Cost of computers, communications and other services (% of commerical service exports) in Jamaica in 2007 to that in 2012?
Ensure brevity in your answer.  0.9. What is the ratio of the Cost of computers, communications and other services (% of commerical service exports) in Lesotho in 2007 to that in 2012?
Give a very brief answer. 0.5. What is the ratio of the Cost of computers, communications and other services (% of commerical service exports) in Macao in 2007 to that in 2012?
Keep it short and to the point. 0.91. What is the ratio of the Cost of computers, communications and other services (% of commerical service exports) in Jamaica in 2008 to that in 2009?
Offer a very short reply. 0.87. What is the ratio of the Cost of computers, communications and other services (% of commerical service exports) of Lesotho in 2008 to that in 2009?
Your answer should be very brief. 0.75. What is the ratio of the Cost of computers, communications and other services (% of commerical service exports) of Macao in 2008 to that in 2009?
Offer a terse response. 1.04. What is the ratio of the Cost of computers, communications and other services (% of commerical service exports) in Jamaica in 2008 to that in 2010?
Your answer should be compact. 0.81. What is the ratio of the Cost of computers, communications and other services (% of commerical service exports) of Lesotho in 2008 to that in 2010?
Offer a very short reply. 1.34. What is the ratio of the Cost of computers, communications and other services (% of commerical service exports) of Macao in 2008 to that in 2010?
Your response must be concise. 0.99. What is the ratio of the Cost of computers, communications and other services (% of commerical service exports) of Jamaica in 2008 to that in 2011?
Provide a succinct answer. 0.82. What is the ratio of the Cost of computers, communications and other services (% of commerical service exports) of Lesotho in 2008 to that in 2011?
Give a very brief answer. 1.18. What is the ratio of the Cost of computers, communications and other services (% of commerical service exports) of Macao in 2008 to that in 2011?
Your answer should be very brief. 0.95. What is the ratio of the Cost of computers, communications and other services (% of commerical service exports) of Jamaica in 2008 to that in 2012?
Give a very brief answer. 0.84. What is the ratio of the Cost of computers, communications and other services (% of commerical service exports) of Lesotho in 2008 to that in 2012?
Your answer should be very brief. 1.13. What is the ratio of the Cost of computers, communications and other services (% of commerical service exports) in Macao in 2008 to that in 2012?
Keep it short and to the point. 0.96. What is the ratio of the Cost of computers, communications and other services (% of commerical service exports) in Jamaica in 2009 to that in 2010?
Provide a succinct answer. 0.93. What is the ratio of the Cost of computers, communications and other services (% of commerical service exports) of Lesotho in 2009 to that in 2010?
Your response must be concise. 1.78. What is the ratio of the Cost of computers, communications and other services (% of commerical service exports) of Macao in 2009 to that in 2010?
Provide a succinct answer. 0.95. What is the ratio of the Cost of computers, communications and other services (% of commerical service exports) of Jamaica in 2009 to that in 2011?
Make the answer very short. 0.94. What is the ratio of the Cost of computers, communications and other services (% of commerical service exports) in Lesotho in 2009 to that in 2011?
Give a very brief answer. 1.58. What is the ratio of the Cost of computers, communications and other services (% of commerical service exports) of Macao in 2009 to that in 2011?
Give a very brief answer. 0.91. What is the ratio of the Cost of computers, communications and other services (% of commerical service exports) of Jamaica in 2009 to that in 2012?
Give a very brief answer. 0.96. What is the ratio of the Cost of computers, communications and other services (% of commerical service exports) in Lesotho in 2009 to that in 2012?
Offer a very short reply. 1.51. What is the ratio of the Cost of computers, communications and other services (% of commerical service exports) of Macao in 2009 to that in 2012?
Provide a short and direct response. 0.93. What is the ratio of the Cost of computers, communications and other services (% of commerical service exports) in Jamaica in 2010 to that in 2011?
Your answer should be very brief. 1.01. What is the ratio of the Cost of computers, communications and other services (% of commerical service exports) in Lesotho in 2010 to that in 2011?
Give a very brief answer. 0.89. What is the ratio of the Cost of computers, communications and other services (% of commerical service exports) of Macao in 2010 to that in 2011?
Ensure brevity in your answer.  0.96. What is the ratio of the Cost of computers, communications and other services (% of commerical service exports) of Jamaica in 2010 to that in 2012?
Give a very brief answer. 1.04. What is the ratio of the Cost of computers, communications and other services (% of commerical service exports) in Lesotho in 2010 to that in 2012?
Ensure brevity in your answer.  0.85. What is the ratio of the Cost of computers, communications and other services (% of commerical service exports) of Macao in 2010 to that in 2012?
Ensure brevity in your answer.  0.98. What is the ratio of the Cost of computers, communications and other services (% of commerical service exports) in Jamaica in 2011 to that in 2012?
Provide a short and direct response. 1.03. What is the ratio of the Cost of computers, communications and other services (% of commerical service exports) in Lesotho in 2011 to that in 2012?
Provide a succinct answer. 0.95. What is the ratio of the Cost of computers, communications and other services (% of commerical service exports) in Macao in 2011 to that in 2012?
Your answer should be compact. 1.02. What is the difference between the highest and the second highest Cost of computers, communications and other services (% of commerical service exports) of Jamaica?
Give a very brief answer. 0.37. What is the difference between the highest and the second highest Cost of computers, communications and other services (% of commerical service exports) in Lesotho?
Your response must be concise. 6.3. What is the difference between the highest and the second highest Cost of computers, communications and other services (% of commerical service exports) of Macao?
Your response must be concise. 1.46. What is the difference between the highest and the lowest Cost of computers, communications and other services (% of commerical service exports) of Jamaica?
Your answer should be compact. 6.99. What is the difference between the highest and the lowest Cost of computers, communications and other services (% of commerical service exports) of Lesotho?
Provide a short and direct response. 16.77. What is the difference between the highest and the lowest Cost of computers, communications and other services (% of commerical service exports) in Macao?
Your answer should be compact. 19.24. 